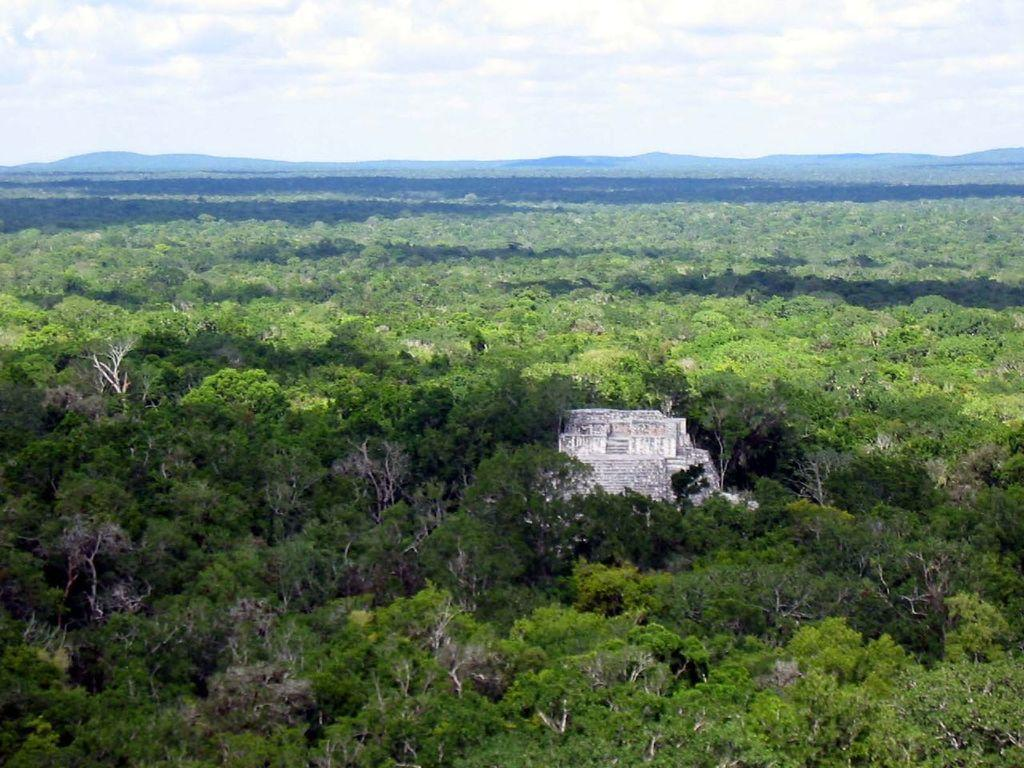What type of vegetation can be seen in the image? There are trees in the image. What structure is located in the middle of the image? There appears to be a wall in the middle of the image. What is visible at the top of the image? The sky is visible in the image. How would you describe the sky in the image? The sky appears to be cloudy. Can you see a boy writing letters on the wall in the image? There is no boy or letters written on the wall in the image. How does the wall maintain its balance in the image? The wall does not need to maintain its balance, as it is a stationary structure in the image. 